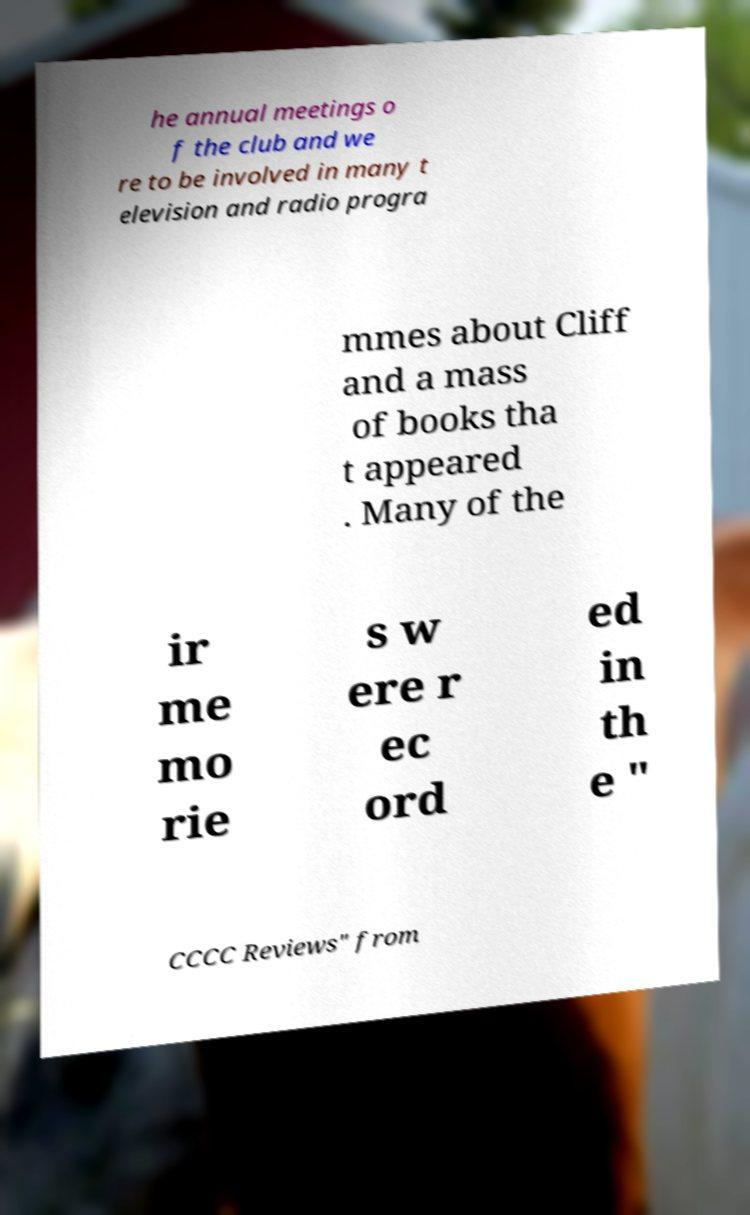Can you accurately transcribe the text from the provided image for me? he annual meetings o f the club and we re to be involved in many t elevision and radio progra mmes about Cliff and a mass of books tha t appeared . Many of the ir me mo rie s w ere r ec ord ed in th e " CCCC Reviews" from 